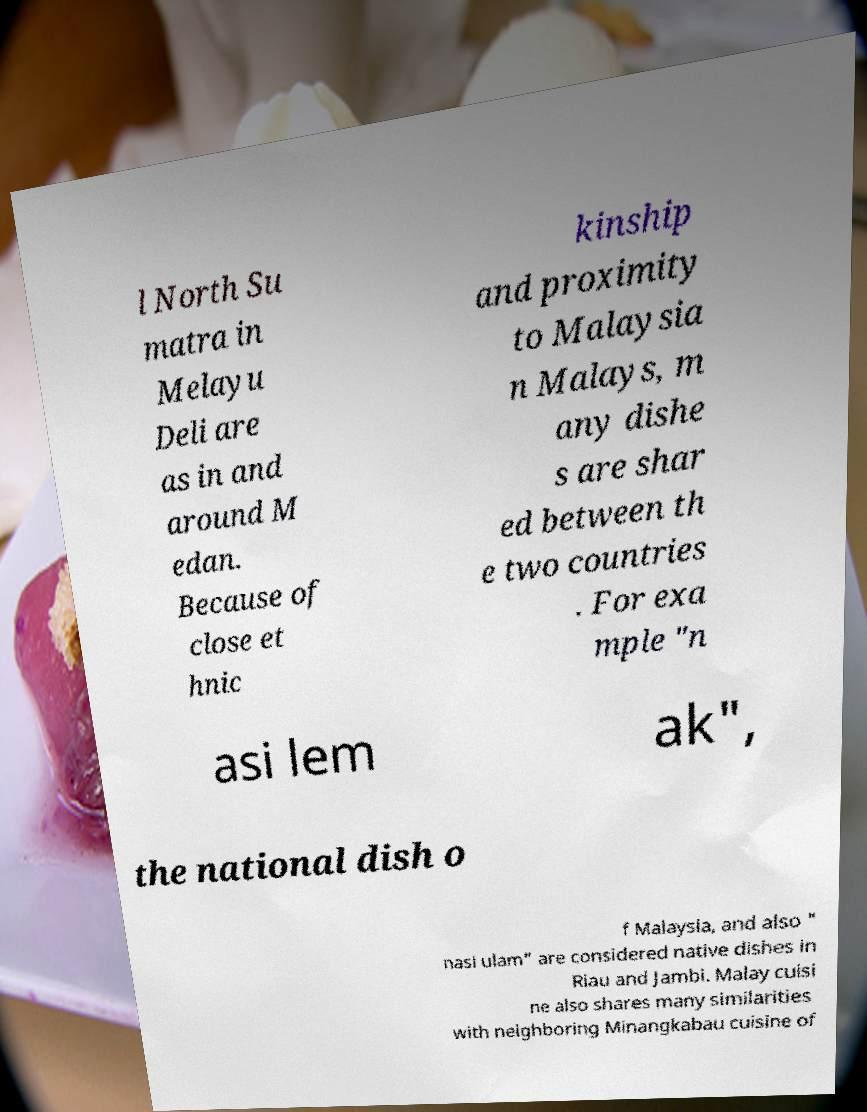Could you extract and type out the text from this image? l North Su matra in Melayu Deli are as in and around M edan. Because of close et hnic kinship and proximity to Malaysia n Malays, m any dishe s are shar ed between th e two countries . For exa mple "n asi lem ak", the national dish o f Malaysia, and also " nasi ulam" are considered native dishes in Riau and Jambi. Malay cuisi ne also shares many similarities with neighboring Minangkabau cuisine of 